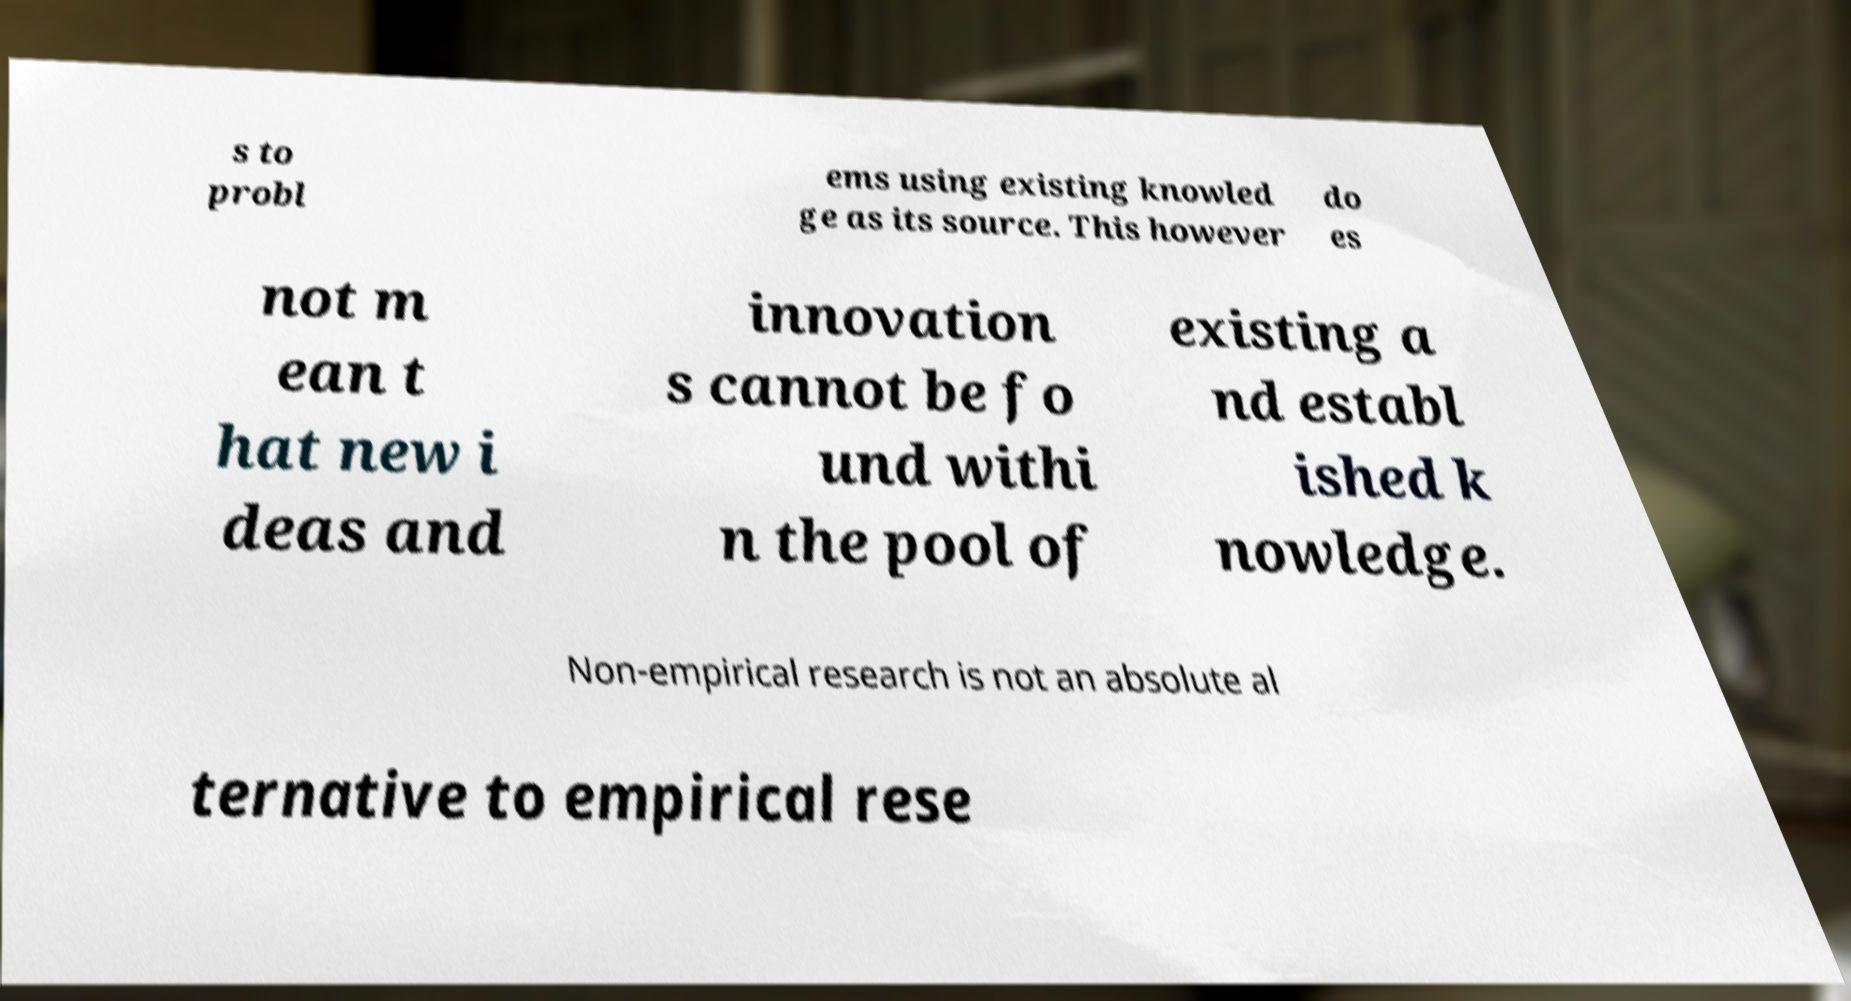Can you read and provide the text displayed in the image?This photo seems to have some interesting text. Can you extract and type it out for me? s to probl ems using existing knowled ge as its source. This however do es not m ean t hat new i deas and innovation s cannot be fo und withi n the pool of existing a nd establ ished k nowledge. Non-empirical research is not an absolute al ternative to empirical rese 